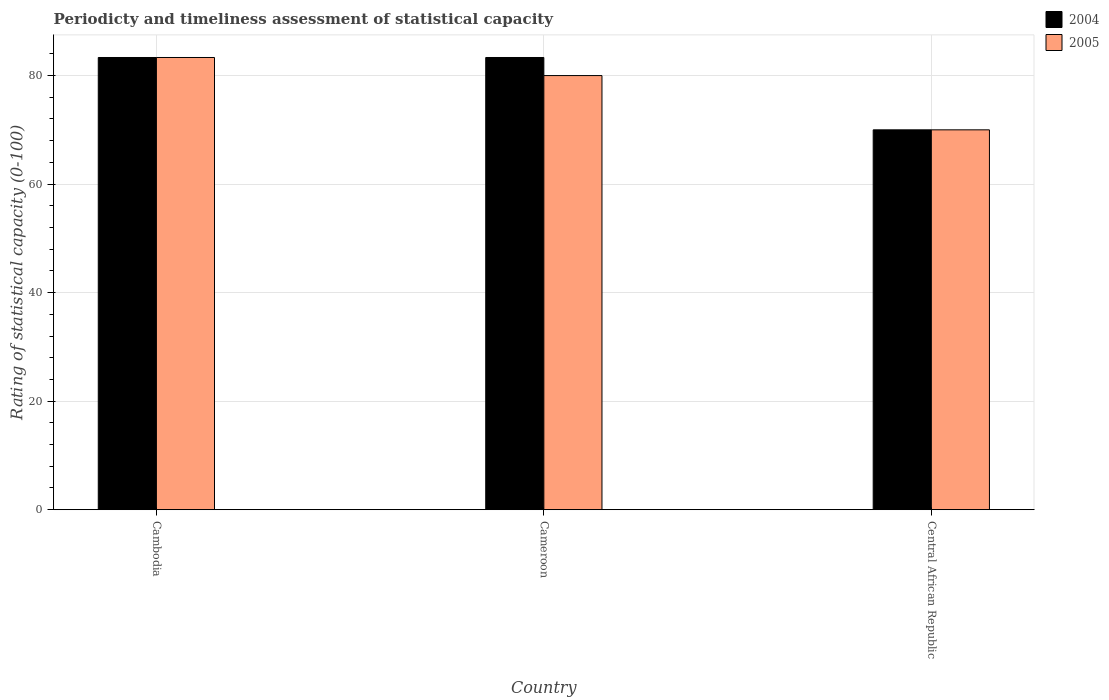Are the number of bars on each tick of the X-axis equal?
Your response must be concise. Yes. What is the label of the 2nd group of bars from the left?
Make the answer very short. Cameroon. In how many cases, is the number of bars for a given country not equal to the number of legend labels?
Ensure brevity in your answer.  0. What is the rating of statistical capacity in 2005 in Cameroon?
Ensure brevity in your answer.  80. Across all countries, what is the maximum rating of statistical capacity in 2004?
Provide a short and direct response. 83.33. In which country was the rating of statistical capacity in 2004 maximum?
Your response must be concise. Cambodia. In which country was the rating of statistical capacity in 2005 minimum?
Keep it short and to the point. Central African Republic. What is the total rating of statistical capacity in 2004 in the graph?
Offer a very short reply. 236.67. What is the average rating of statistical capacity in 2005 per country?
Ensure brevity in your answer.  77.78. What is the difference between the rating of statistical capacity of/in 2005 and rating of statistical capacity of/in 2004 in Cameroon?
Ensure brevity in your answer.  -3.33. What is the ratio of the rating of statistical capacity in 2005 in Cambodia to that in Central African Republic?
Your answer should be very brief. 1.19. Is the rating of statistical capacity in 2005 in Cameroon less than that in Central African Republic?
Offer a terse response. No. Is the difference between the rating of statistical capacity in 2005 in Cambodia and Central African Republic greater than the difference between the rating of statistical capacity in 2004 in Cambodia and Central African Republic?
Your answer should be compact. No. What is the difference between the highest and the second highest rating of statistical capacity in 2005?
Offer a terse response. -3.33. What is the difference between the highest and the lowest rating of statistical capacity in 2004?
Provide a short and direct response. 13.33. In how many countries, is the rating of statistical capacity in 2005 greater than the average rating of statistical capacity in 2005 taken over all countries?
Provide a succinct answer. 2. Is the sum of the rating of statistical capacity in 2005 in Cambodia and Cameroon greater than the maximum rating of statistical capacity in 2004 across all countries?
Offer a terse response. Yes. What does the 1st bar from the left in Cambodia represents?
Your answer should be compact. 2004. What does the 1st bar from the right in Cameroon represents?
Your answer should be very brief. 2005. How many legend labels are there?
Provide a succinct answer. 2. What is the title of the graph?
Your answer should be very brief. Periodicty and timeliness assessment of statistical capacity. What is the label or title of the X-axis?
Offer a very short reply. Country. What is the label or title of the Y-axis?
Give a very brief answer. Rating of statistical capacity (0-100). What is the Rating of statistical capacity (0-100) of 2004 in Cambodia?
Your answer should be very brief. 83.33. What is the Rating of statistical capacity (0-100) of 2005 in Cambodia?
Offer a very short reply. 83.33. What is the Rating of statistical capacity (0-100) of 2004 in Cameroon?
Offer a very short reply. 83.33. What is the Rating of statistical capacity (0-100) of 2005 in Cameroon?
Your response must be concise. 80. What is the Rating of statistical capacity (0-100) in 2004 in Central African Republic?
Provide a short and direct response. 70. What is the Rating of statistical capacity (0-100) of 2005 in Central African Republic?
Your answer should be compact. 70. Across all countries, what is the maximum Rating of statistical capacity (0-100) of 2004?
Give a very brief answer. 83.33. Across all countries, what is the maximum Rating of statistical capacity (0-100) of 2005?
Your answer should be compact. 83.33. Across all countries, what is the minimum Rating of statistical capacity (0-100) of 2005?
Make the answer very short. 70. What is the total Rating of statistical capacity (0-100) of 2004 in the graph?
Your response must be concise. 236.67. What is the total Rating of statistical capacity (0-100) in 2005 in the graph?
Your response must be concise. 233.33. What is the difference between the Rating of statistical capacity (0-100) of 2004 in Cambodia and that in Central African Republic?
Keep it short and to the point. 13.33. What is the difference between the Rating of statistical capacity (0-100) in 2005 in Cambodia and that in Central African Republic?
Offer a very short reply. 13.33. What is the difference between the Rating of statistical capacity (0-100) in 2004 in Cameroon and that in Central African Republic?
Offer a terse response. 13.33. What is the difference between the Rating of statistical capacity (0-100) in 2004 in Cambodia and the Rating of statistical capacity (0-100) in 2005 in Central African Republic?
Provide a short and direct response. 13.33. What is the difference between the Rating of statistical capacity (0-100) of 2004 in Cameroon and the Rating of statistical capacity (0-100) of 2005 in Central African Republic?
Provide a succinct answer. 13.33. What is the average Rating of statistical capacity (0-100) in 2004 per country?
Offer a terse response. 78.89. What is the average Rating of statistical capacity (0-100) in 2005 per country?
Your answer should be compact. 77.78. What is the difference between the Rating of statistical capacity (0-100) of 2004 and Rating of statistical capacity (0-100) of 2005 in Cameroon?
Your response must be concise. 3.33. What is the difference between the Rating of statistical capacity (0-100) of 2004 and Rating of statistical capacity (0-100) of 2005 in Central African Republic?
Make the answer very short. 0. What is the ratio of the Rating of statistical capacity (0-100) in 2004 in Cambodia to that in Cameroon?
Make the answer very short. 1. What is the ratio of the Rating of statistical capacity (0-100) of 2005 in Cambodia to that in Cameroon?
Offer a terse response. 1.04. What is the ratio of the Rating of statistical capacity (0-100) in 2004 in Cambodia to that in Central African Republic?
Offer a terse response. 1.19. What is the ratio of the Rating of statistical capacity (0-100) in 2005 in Cambodia to that in Central African Republic?
Ensure brevity in your answer.  1.19. What is the ratio of the Rating of statistical capacity (0-100) of 2004 in Cameroon to that in Central African Republic?
Your answer should be very brief. 1.19. What is the ratio of the Rating of statistical capacity (0-100) in 2005 in Cameroon to that in Central African Republic?
Provide a short and direct response. 1.14. What is the difference between the highest and the second highest Rating of statistical capacity (0-100) in 2004?
Ensure brevity in your answer.  0. What is the difference between the highest and the second highest Rating of statistical capacity (0-100) in 2005?
Your answer should be compact. 3.33. What is the difference between the highest and the lowest Rating of statistical capacity (0-100) of 2004?
Give a very brief answer. 13.33. What is the difference between the highest and the lowest Rating of statistical capacity (0-100) of 2005?
Provide a succinct answer. 13.33. 